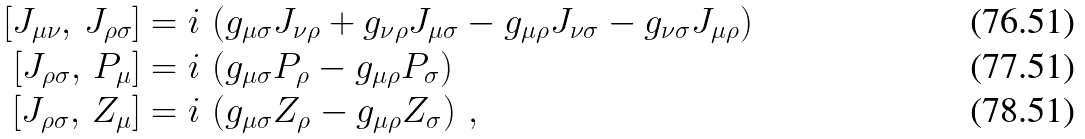Convert formula to latex. <formula><loc_0><loc_0><loc_500><loc_500>[ J _ { \mu \nu } , \, J _ { \rho \sigma } ] & = i \, \left ( g _ { \mu \sigma } J _ { \nu \rho } + g _ { \nu \rho } J _ { \mu \sigma } - g _ { \mu \rho } J _ { \nu \sigma } - g _ { \nu \sigma } J _ { \mu \rho } \right ) \\ [ J _ { \rho \sigma } , \, P _ { \mu } ] & = i \, \left ( g _ { \mu \sigma } P _ { \rho } - g _ { \mu \rho } P _ { \sigma } \right ) \\ [ J _ { \rho \sigma } , \, Z _ { \mu } ] & = i \, \left ( g _ { \mu \sigma } Z _ { \rho } - g _ { \mu \rho } Z _ { \sigma } \right ) \, ,</formula> 